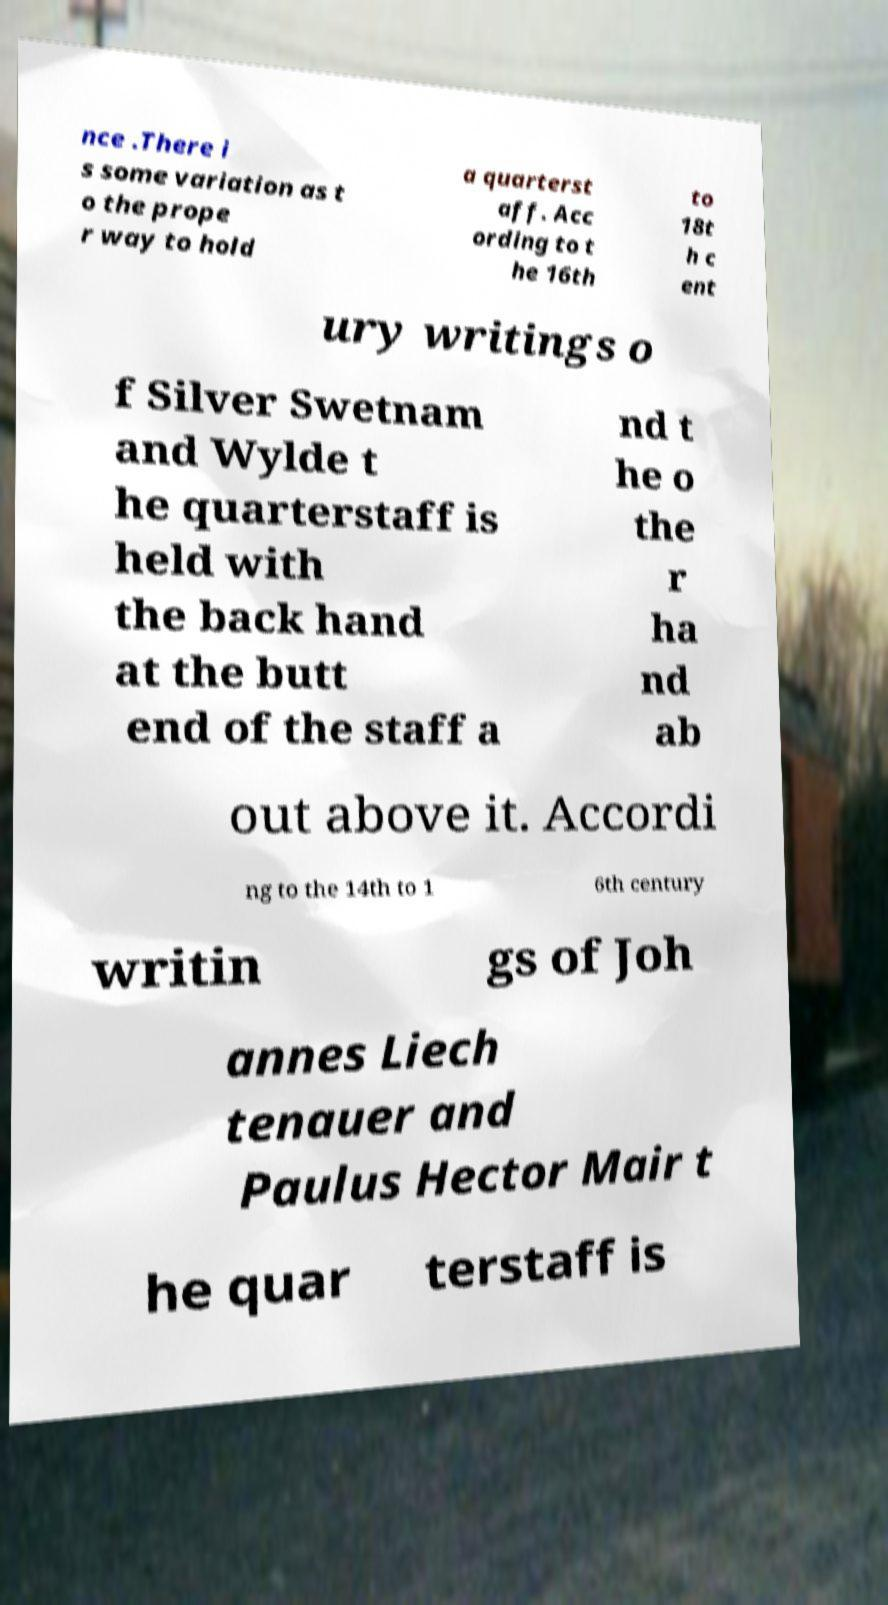Could you extract and type out the text from this image? nce .There i s some variation as t o the prope r way to hold a quarterst aff. Acc ording to t he 16th to 18t h c ent ury writings o f Silver Swetnam and Wylde t he quarterstaff is held with the back hand at the butt end of the staff a nd t he o the r ha nd ab out above it. Accordi ng to the 14th to 1 6th century writin gs of Joh annes Liech tenauer and Paulus Hector Mair t he quar terstaff is 